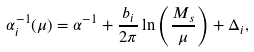Convert formula to latex. <formula><loc_0><loc_0><loc_500><loc_500>\alpha _ { i } ^ { - 1 } ( \mu ) = \alpha ^ { - 1 } + { \frac { b _ { i } } { 2 \pi } } \ln \left ( { \frac { M _ { s } } { \mu } } \right ) + \Delta _ { i } ,</formula> 